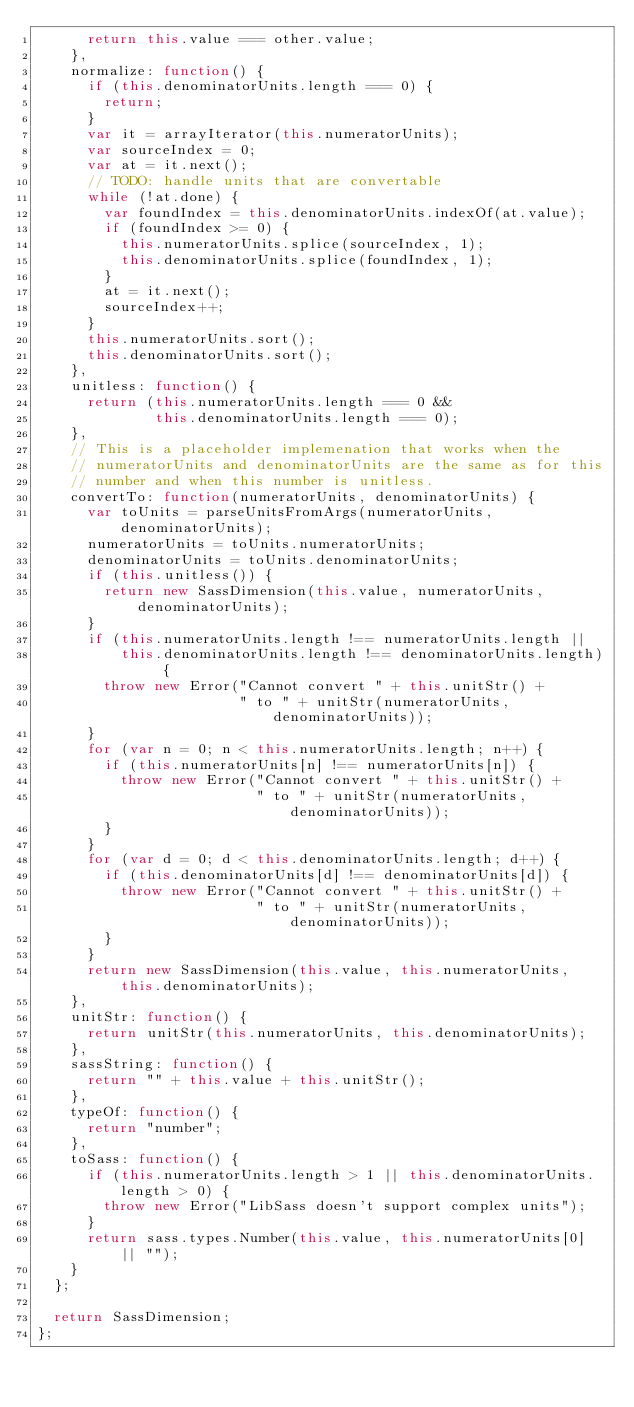<code> <loc_0><loc_0><loc_500><loc_500><_JavaScript_>      return this.value === other.value;
    },
    normalize: function() {
      if (this.denominatorUnits.length === 0) {
        return;
      }
      var it = arrayIterator(this.numeratorUnits);
      var sourceIndex = 0;
      var at = it.next();
      // TODO: handle units that are convertable
      while (!at.done) {
        var foundIndex = this.denominatorUnits.indexOf(at.value);
        if (foundIndex >= 0) {
          this.numeratorUnits.splice(sourceIndex, 1);
          this.denominatorUnits.splice(foundIndex, 1);
        }
        at = it.next();
        sourceIndex++;
      }
      this.numeratorUnits.sort();
      this.denominatorUnits.sort();
    },
    unitless: function() {
      return (this.numeratorUnits.length === 0 &&
              this.denominatorUnits.length === 0);
    },
    // This is a placeholder implemenation that works when the
    // numeratorUnits and denominatorUnits are the same as for this
    // number and when this number is unitless.
    convertTo: function(numeratorUnits, denominatorUnits) {
      var toUnits = parseUnitsFromArgs(numeratorUnits, denominatorUnits);
      numeratorUnits = toUnits.numeratorUnits;
      denominatorUnits = toUnits.denominatorUnits;
      if (this.unitless()) {
        return new SassDimension(this.value, numeratorUnits, denominatorUnits);
      }
      if (this.numeratorUnits.length !== numeratorUnits.length ||
          this.denominatorUnits.length !== denominatorUnits.length) {
        throw new Error("Cannot convert " + this.unitStr() +
                        " to " + unitStr(numeratorUnits, denominatorUnits));
      }
      for (var n = 0; n < this.numeratorUnits.length; n++) {
        if (this.numeratorUnits[n] !== numeratorUnits[n]) {
          throw new Error("Cannot convert " + this.unitStr() +
                          " to " + unitStr(numeratorUnits, denominatorUnits));
        }
      }
      for (var d = 0; d < this.denominatorUnits.length; d++) {
        if (this.denominatorUnits[d] !== denominatorUnits[d]) {
          throw new Error("Cannot convert " + this.unitStr() +
                          " to " + unitStr(numeratorUnits, denominatorUnits));
        }
      }
      return new SassDimension(this.value, this.numeratorUnits, this.denominatorUnits);
    },
    unitStr: function() {
      return unitStr(this.numeratorUnits, this.denominatorUnits);
    },
    sassString: function() {
      return "" + this.value + this.unitStr();
    },
    typeOf: function() {
      return "number";
    },
    toSass: function() {
      if (this.numeratorUnits.length > 1 || this.denominatorUnits.length > 0) {
        throw new Error("LibSass doesn't support complex units");
      }
      return sass.types.Number(this.value, this.numeratorUnits[0] || "");
    }
  };

  return SassDimension;
};
</code> 